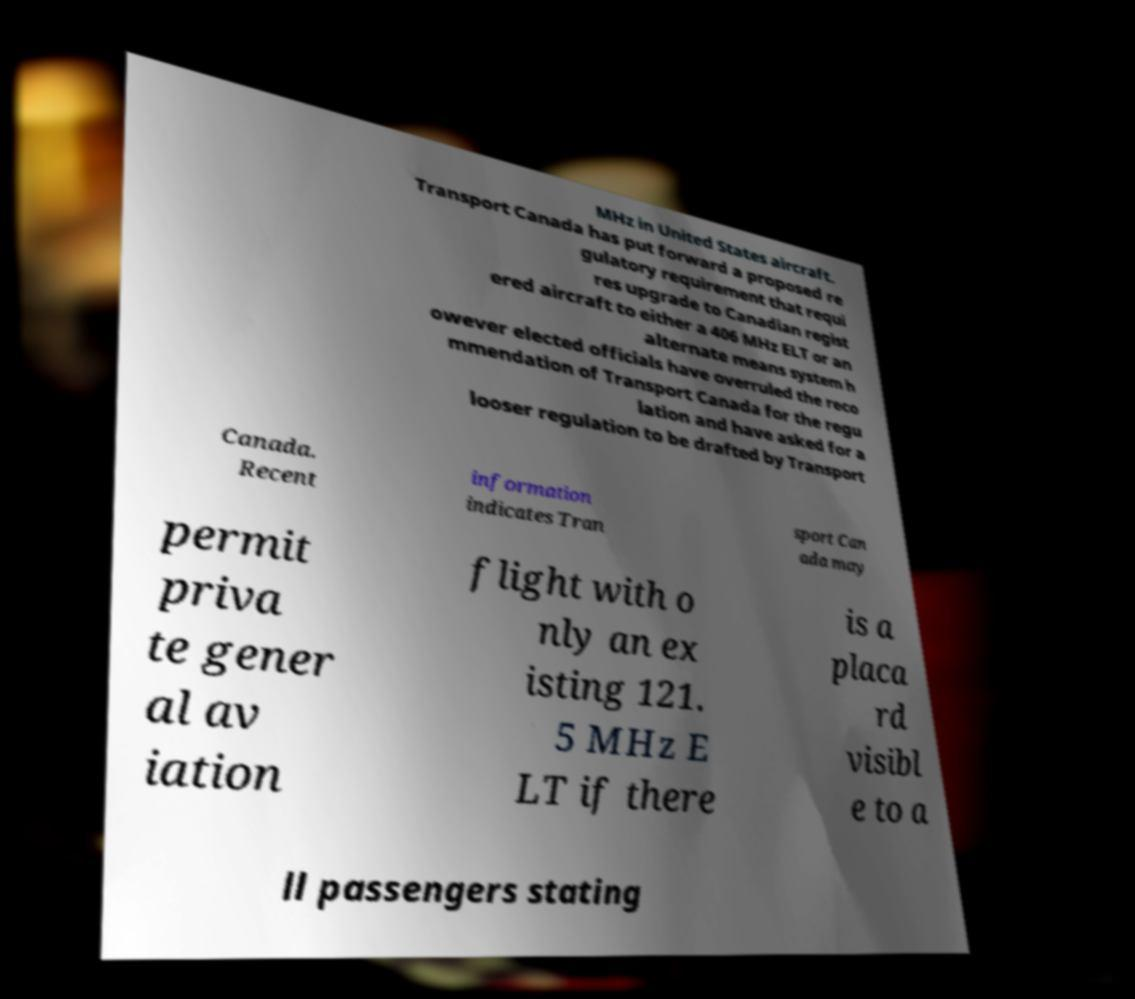For documentation purposes, I need the text within this image transcribed. Could you provide that? MHz in United States aircraft. Transport Canada has put forward a proposed re gulatory requirement that requi res upgrade to Canadian regist ered aircraft to either a 406 MHz ELT or an alternate means system h owever elected officials have overruled the reco mmendation of Transport Canada for the regu lation and have asked for a looser regulation to be drafted by Transport Canada. Recent information indicates Tran sport Can ada may permit priva te gener al av iation flight with o nly an ex isting 121. 5 MHz E LT if there is a placa rd visibl e to a ll passengers stating 